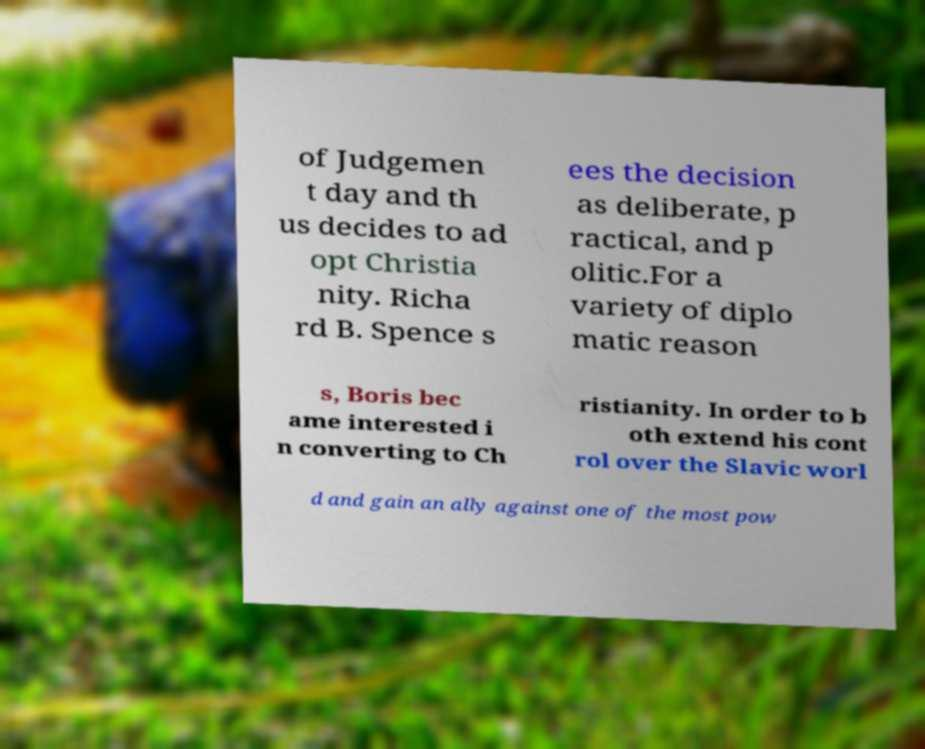Can you accurately transcribe the text from the provided image for me? of Judgemen t day and th us decides to ad opt Christia nity. Richa rd B. Spence s ees the decision as deliberate, p ractical, and p olitic.For a variety of diplo matic reason s, Boris bec ame interested i n converting to Ch ristianity. In order to b oth extend his cont rol over the Slavic worl d and gain an ally against one of the most pow 